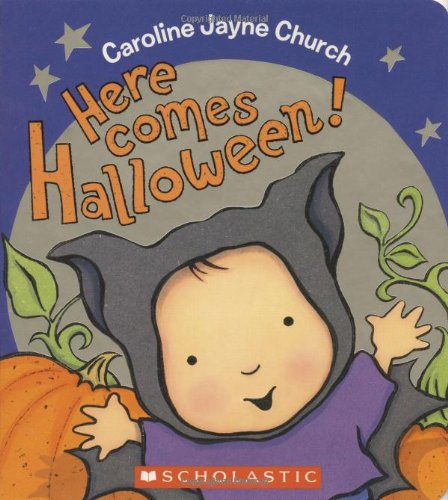Is this book related to Engineering & Transportation? No, this book is not related to Engineering & Transportation. It is focused on the theme of Halloween and is designed for young children, emphasizing fun and learning through storytelling. 